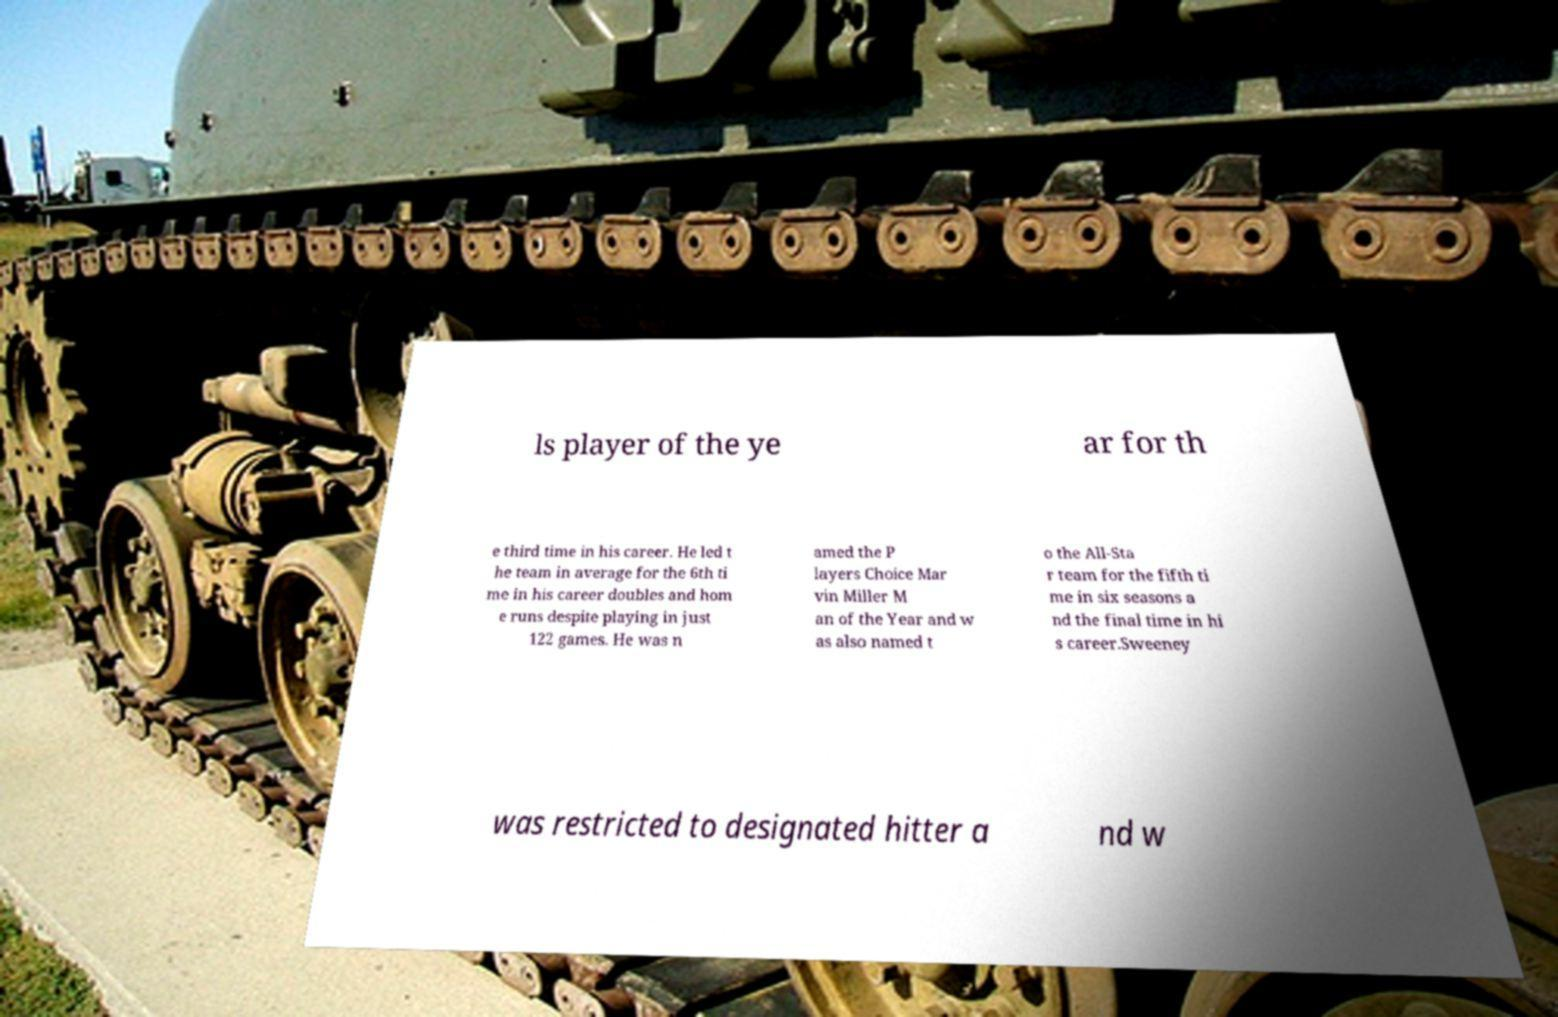I need the written content from this picture converted into text. Can you do that? ls player of the ye ar for th e third time in his career. He led t he team in average for the 6th ti me in his career doubles and hom e runs despite playing in just 122 games. He was n amed the P layers Choice Mar vin Miller M an of the Year and w as also named t o the All-Sta r team for the fifth ti me in six seasons a nd the final time in hi s career.Sweeney was restricted to designated hitter a nd w 